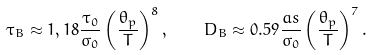Convert formula to latex. <formula><loc_0><loc_0><loc_500><loc_500>\tau _ { B } \approx 1 , 1 8 \frac { \tau _ { 0 } } { \sigma _ { 0 } } \left ( \frac { \theta _ { p } } { T } \right ) ^ { 8 } , \quad D _ { B } \approx 0 . 5 9 \frac { a s } { \sigma _ { 0 } } \left ( \frac { \theta _ { p } } { T } \right ) ^ { 7 } .</formula> 